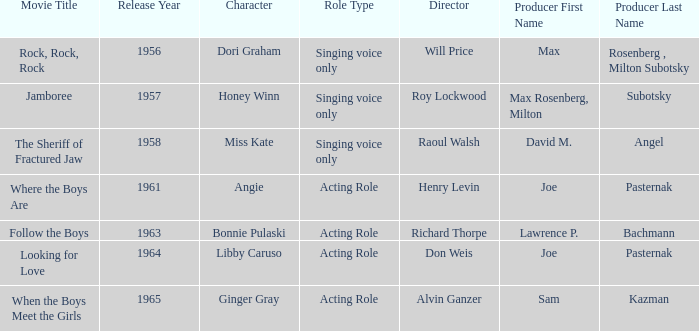What were the roles in 1961? Angie. 